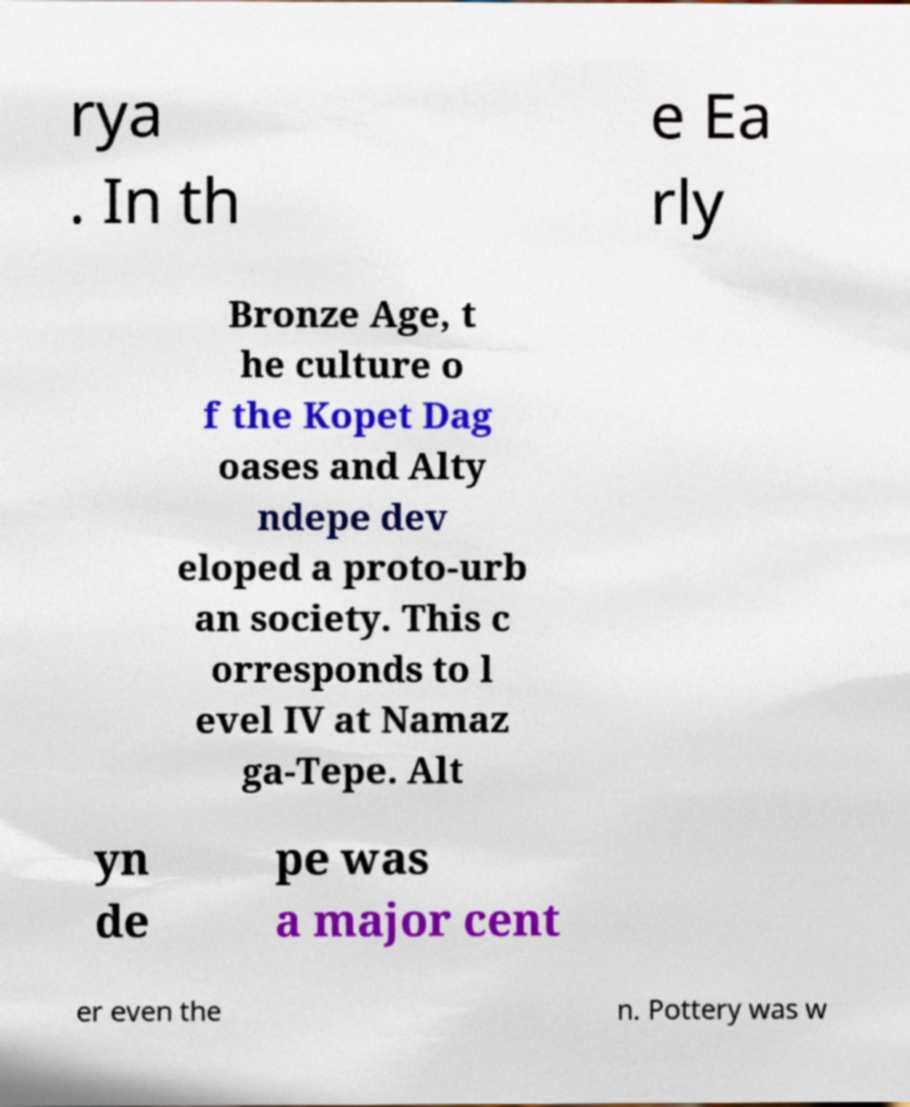I need the written content from this picture converted into text. Can you do that? rya . In th e Ea rly Bronze Age, t he culture o f the Kopet Dag oases and Alty ndepe dev eloped a proto-urb an society. This c orresponds to l evel IV at Namaz ga-Tepe. Alt yn de pe was a major cent er even the n. Pottery was w 